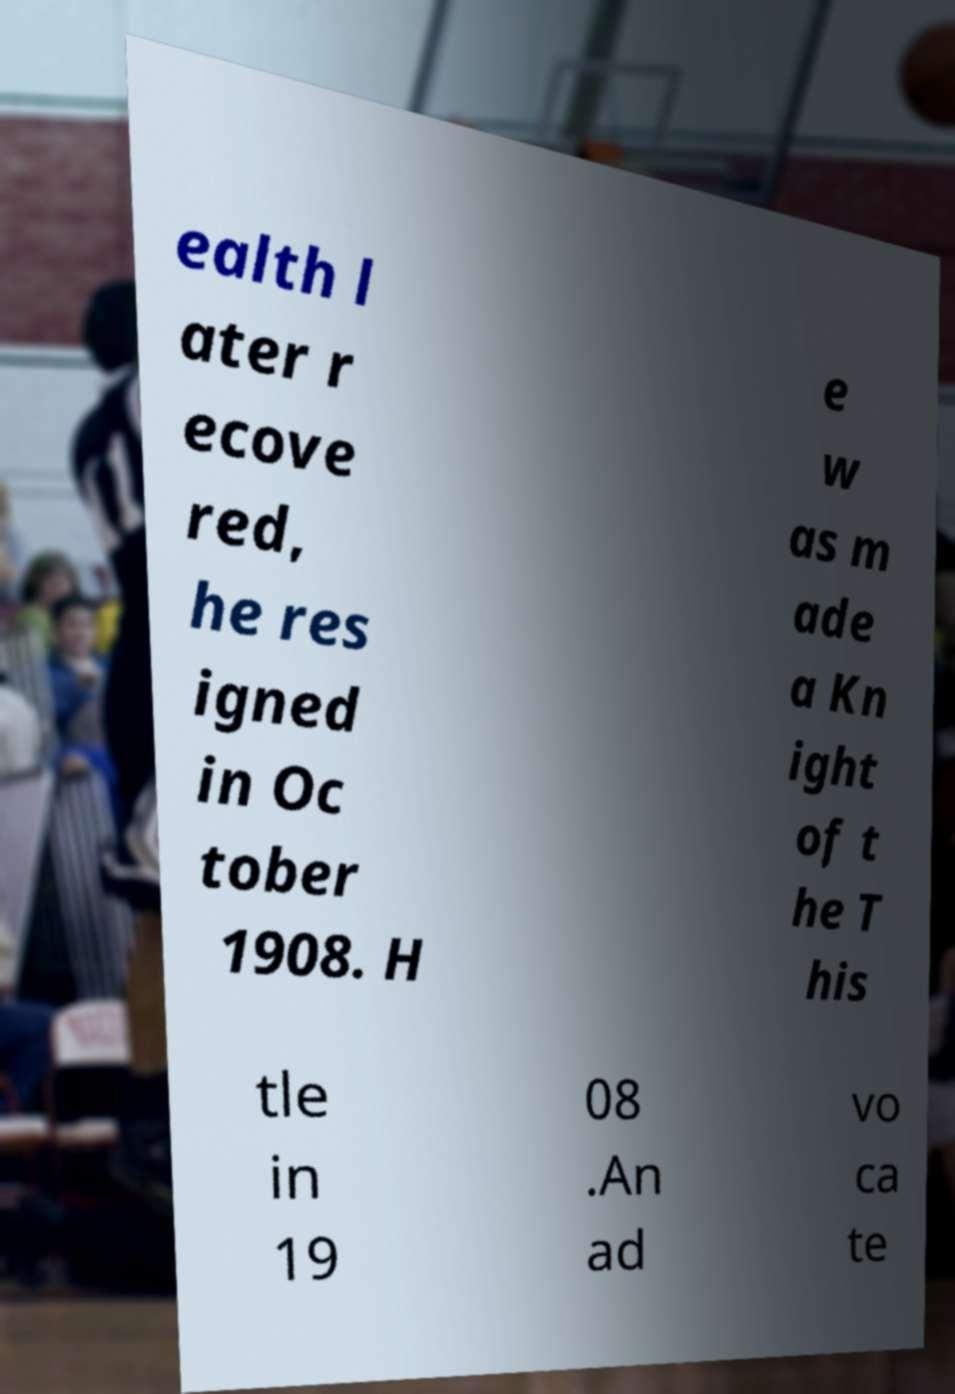Can you read and provide the text displayed in the image?This photo seems to have some interesting text. Can you extract and type it out for me? ealth l ater r ecove red, he res igned in Oc tober 1908. H e w as m ade a Kn ight of t he T his tle in 19 08 .An ad vo ca te 